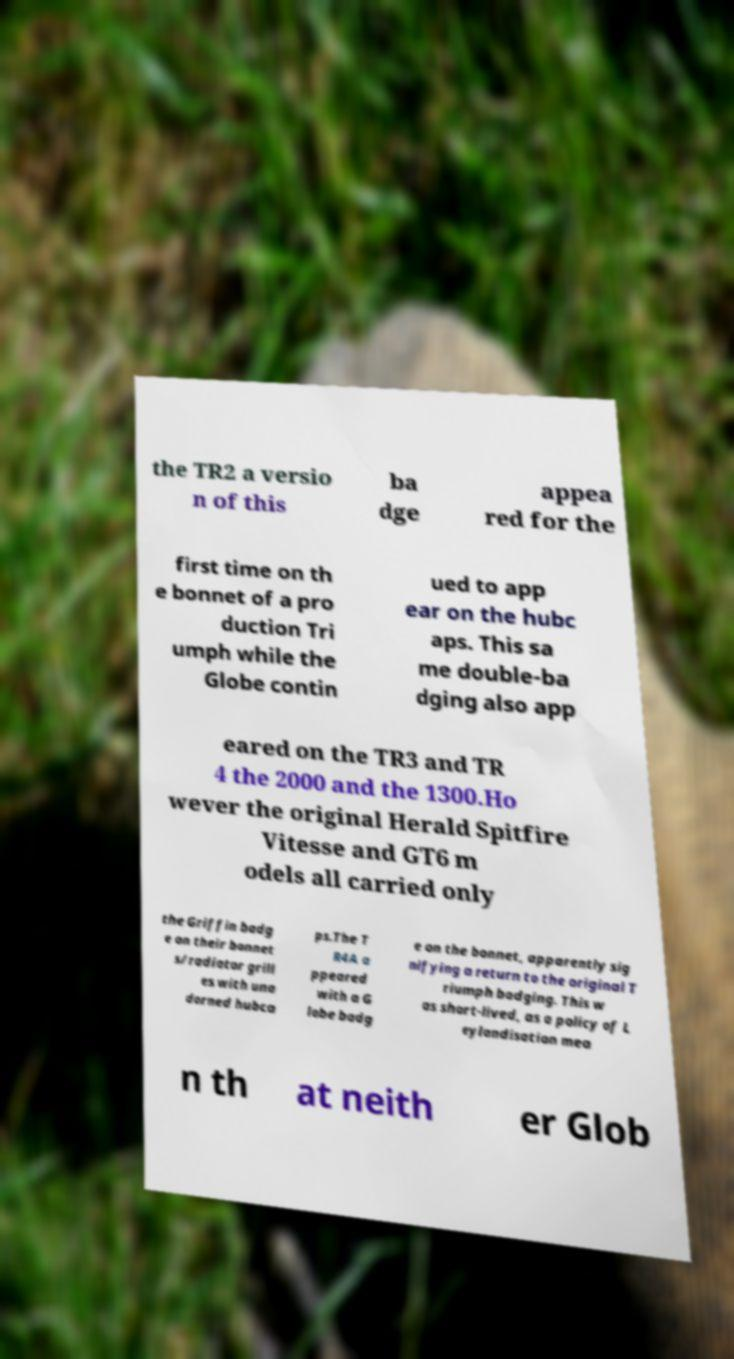Please identify and transcribe the text found in this image. the TR2 a versio n of this ba dge appea red for the first time on th e bonnet of a pro duction Tri umph while the Globe contin ued to app ear on the hubc aps. This sa me double-ba dging also app eared on the TR3 and TR 4 the 2000 and the 1300.Ho wever the original Herald Spitfire Vitesse and GT6 m odels all carried only the Griffin badg e on their bonnet s/radiator grill es with una dorned hubca ps.The T R4A a ppeared with a G lobe badg e on the bonnet, apparently sig nifying a return to the original T riumph badging. This w as short-lived, as a policy of L eylandisation mea n th at neith er Glob 